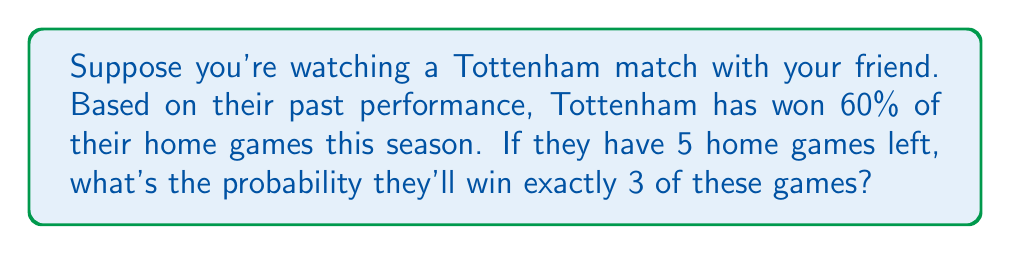Give your solution to this math problem. Let's approach this step-by-step using the binomial probability formula:

1) We're dealing with a binomial probability problem because:
   - There's a fixed number of trials (5 games)
   - Each trial has two possible outcomes (win or not win)
   - The probability of success (winning) is constant for each trial
   - The trials are independent

2) The binomial probability formula is:

   $$ P(X = k) = \binom{n}{k} p^k (1-p)^{n-k} $$

   Where:
   $n$ = number of trials
   $k$ = number of successes
   $p$ = probability of success on each trial

3) In this case:
   $n = 5$ (5 home games)
   $k = 3$ (we want exactly 3 wins)
   $p = 0.60$ (60% chance of winning each game)

4) Let's calculate $\binom{n}{k}$:

   $$ \binom{5}{3} = \frac{5!}{3!(5-3)!} = \frac{5 * 4 * 3}{(3 * 2 * 1)(2 * 1)} = 10 $$

5) Now let's plug everything into the formula:

   $$ P(X = 3) = 10 * (0.60)^3 * (1-0.60)^{5-3} $$
   $$ = 10 * (0.60)^3 * (0.40)^2 $$
   $$ = 10 * 0.216 * 0.16 $$
   $$ = 0.3456 $$

6) Convert to a percentage:
   $0.3456 * 100 = 34.56\%$
Answer: 34.56% 